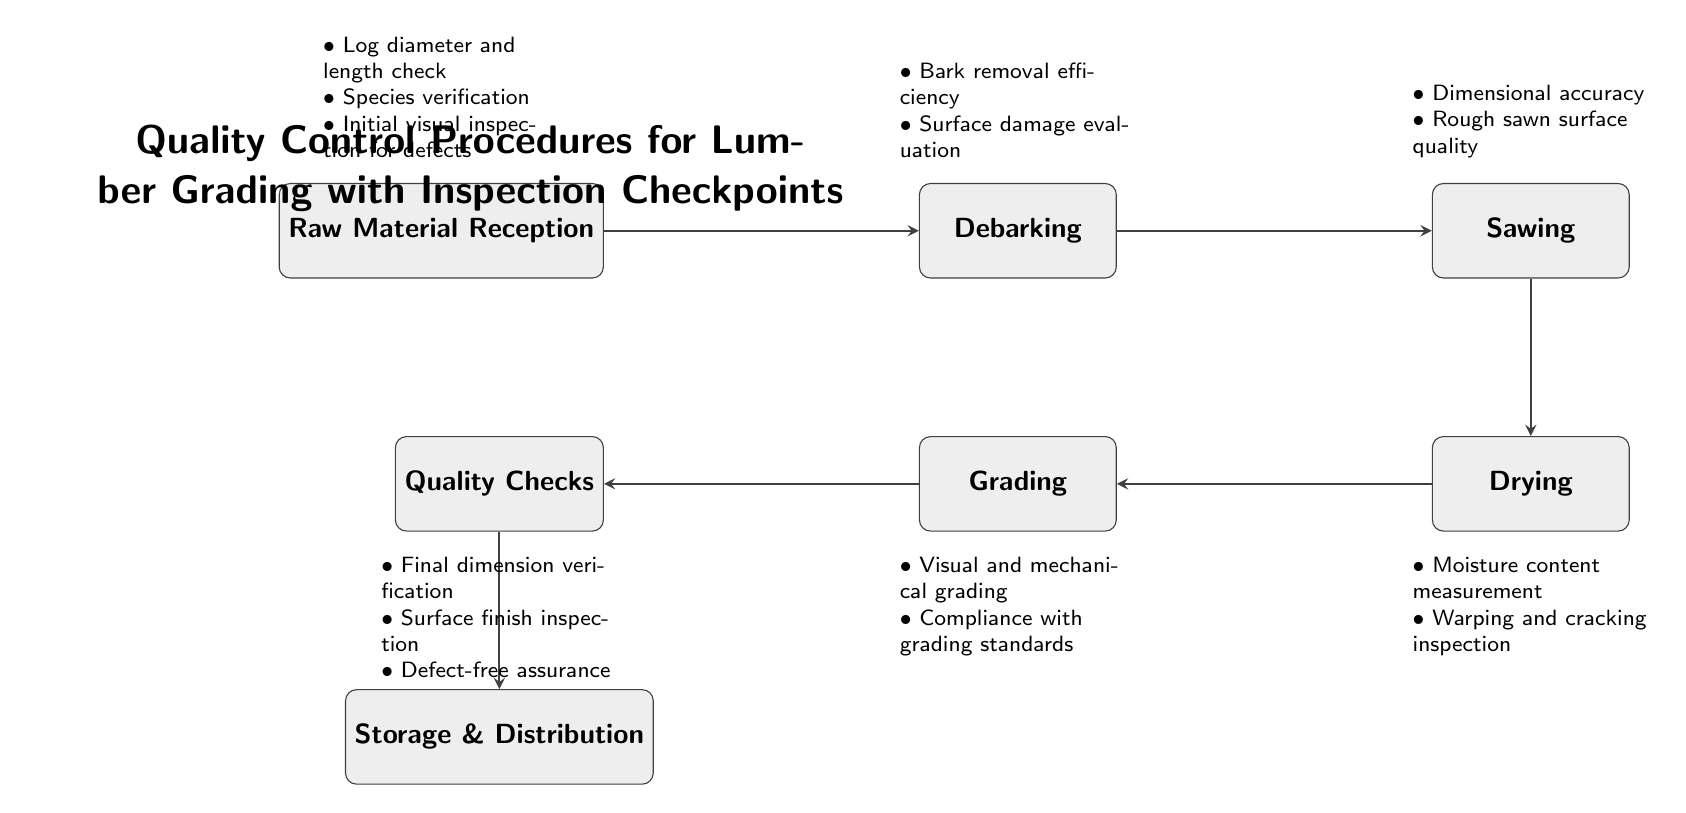What is the starting point of the lumber grading process? The diagram starts with the "Raw Material Reception" node, indicating the first step in the lumber grading process.
Answer: Raw Material Reception How many quality checks are there in the process? The diagram includes one "Quality Checks" node, which is the sixth step in the process.
Answer: 1 What material processing step follows debarking? After the "Debarking" step, the next processing step is "Sawing," as indicated by the directed arrow connecting both nodes.
Answer: Sawing What are the two checkpoints after the grading process? The checkpoints below the "Grading" node include “Visual and mechanical grading” and “Compliance with grading standards,” detailing specific quality measures.
Answer: Visual and mechanical grading, Compliance with grading standards How many steps are there in the lumber processing before storage? By counting the nodes from "Raw Material Reception" to "Quality Checks," there are five processing steps leading up to the final storage stage.
Answer: 5 What is checked during the sawing step? The checkpoints above the "Sawing" node include "Dimensional accuracy" and "Rough sawn surface quality," both of which ensure proper results from the sawing process.
Answer: Dimensional accuracy, Rough sawn surface quality Which process involves moisture content measurement? The "Drying" step involves "Moisture content measurement," as specified in the checklist below the "Drying" node.
Answer: Drying Which process comes immediately before storage and distribution? According to the flow of the diagram, "Quality Checks" is the process that directly precedes "Storage & Distribution."
Answer: Quality Checks What type of inspections occur at the raw material reception? The checkpoints for "Raw Material Reception" include "Log diameter and length check," "Species verification," and "Initial visual inspection for defects," which reflect initial quality control measures.
Answer: Log diameter and length check, Species verification, Initial visual inspection for defects 